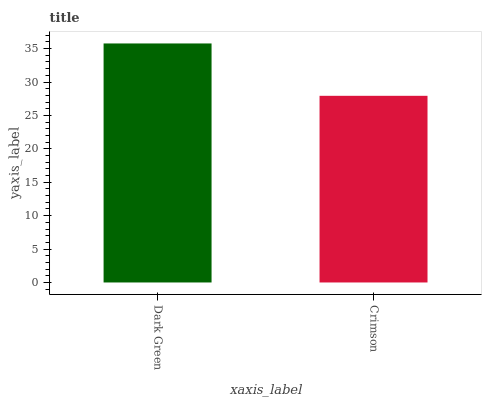Is Crimson the maximum?
Answer yes or no. No. Is Dark Green greater than Crimson?
Answer yes or no. Yes. Is Crimson less than Dark Green?
Answer yes or no. Yes. Is Crimson greater than Dark Green?
Answer yes or no. No. Is Dark Green less than Crimson?
Answer yes or no. No. Is Dark Green the high median?
Answer yes or no. Yes. Is Crimson the low median?
Answer yes or no. Yes. Is Crimson the high median?
Answer yes or no. No. Is Dark Green the low median?
Answer yes or no. No. 